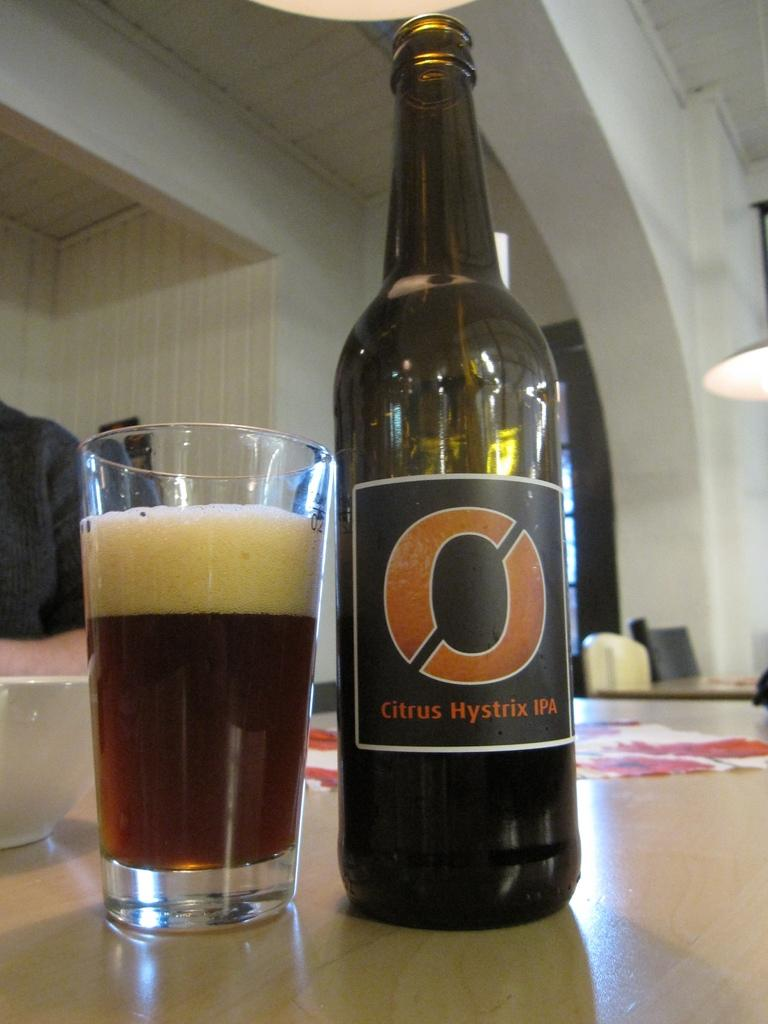<image>
Give a short and clear explanation of the subsequent image. A bottle of Citrus Hystrix IPA is next to a half full glass. 